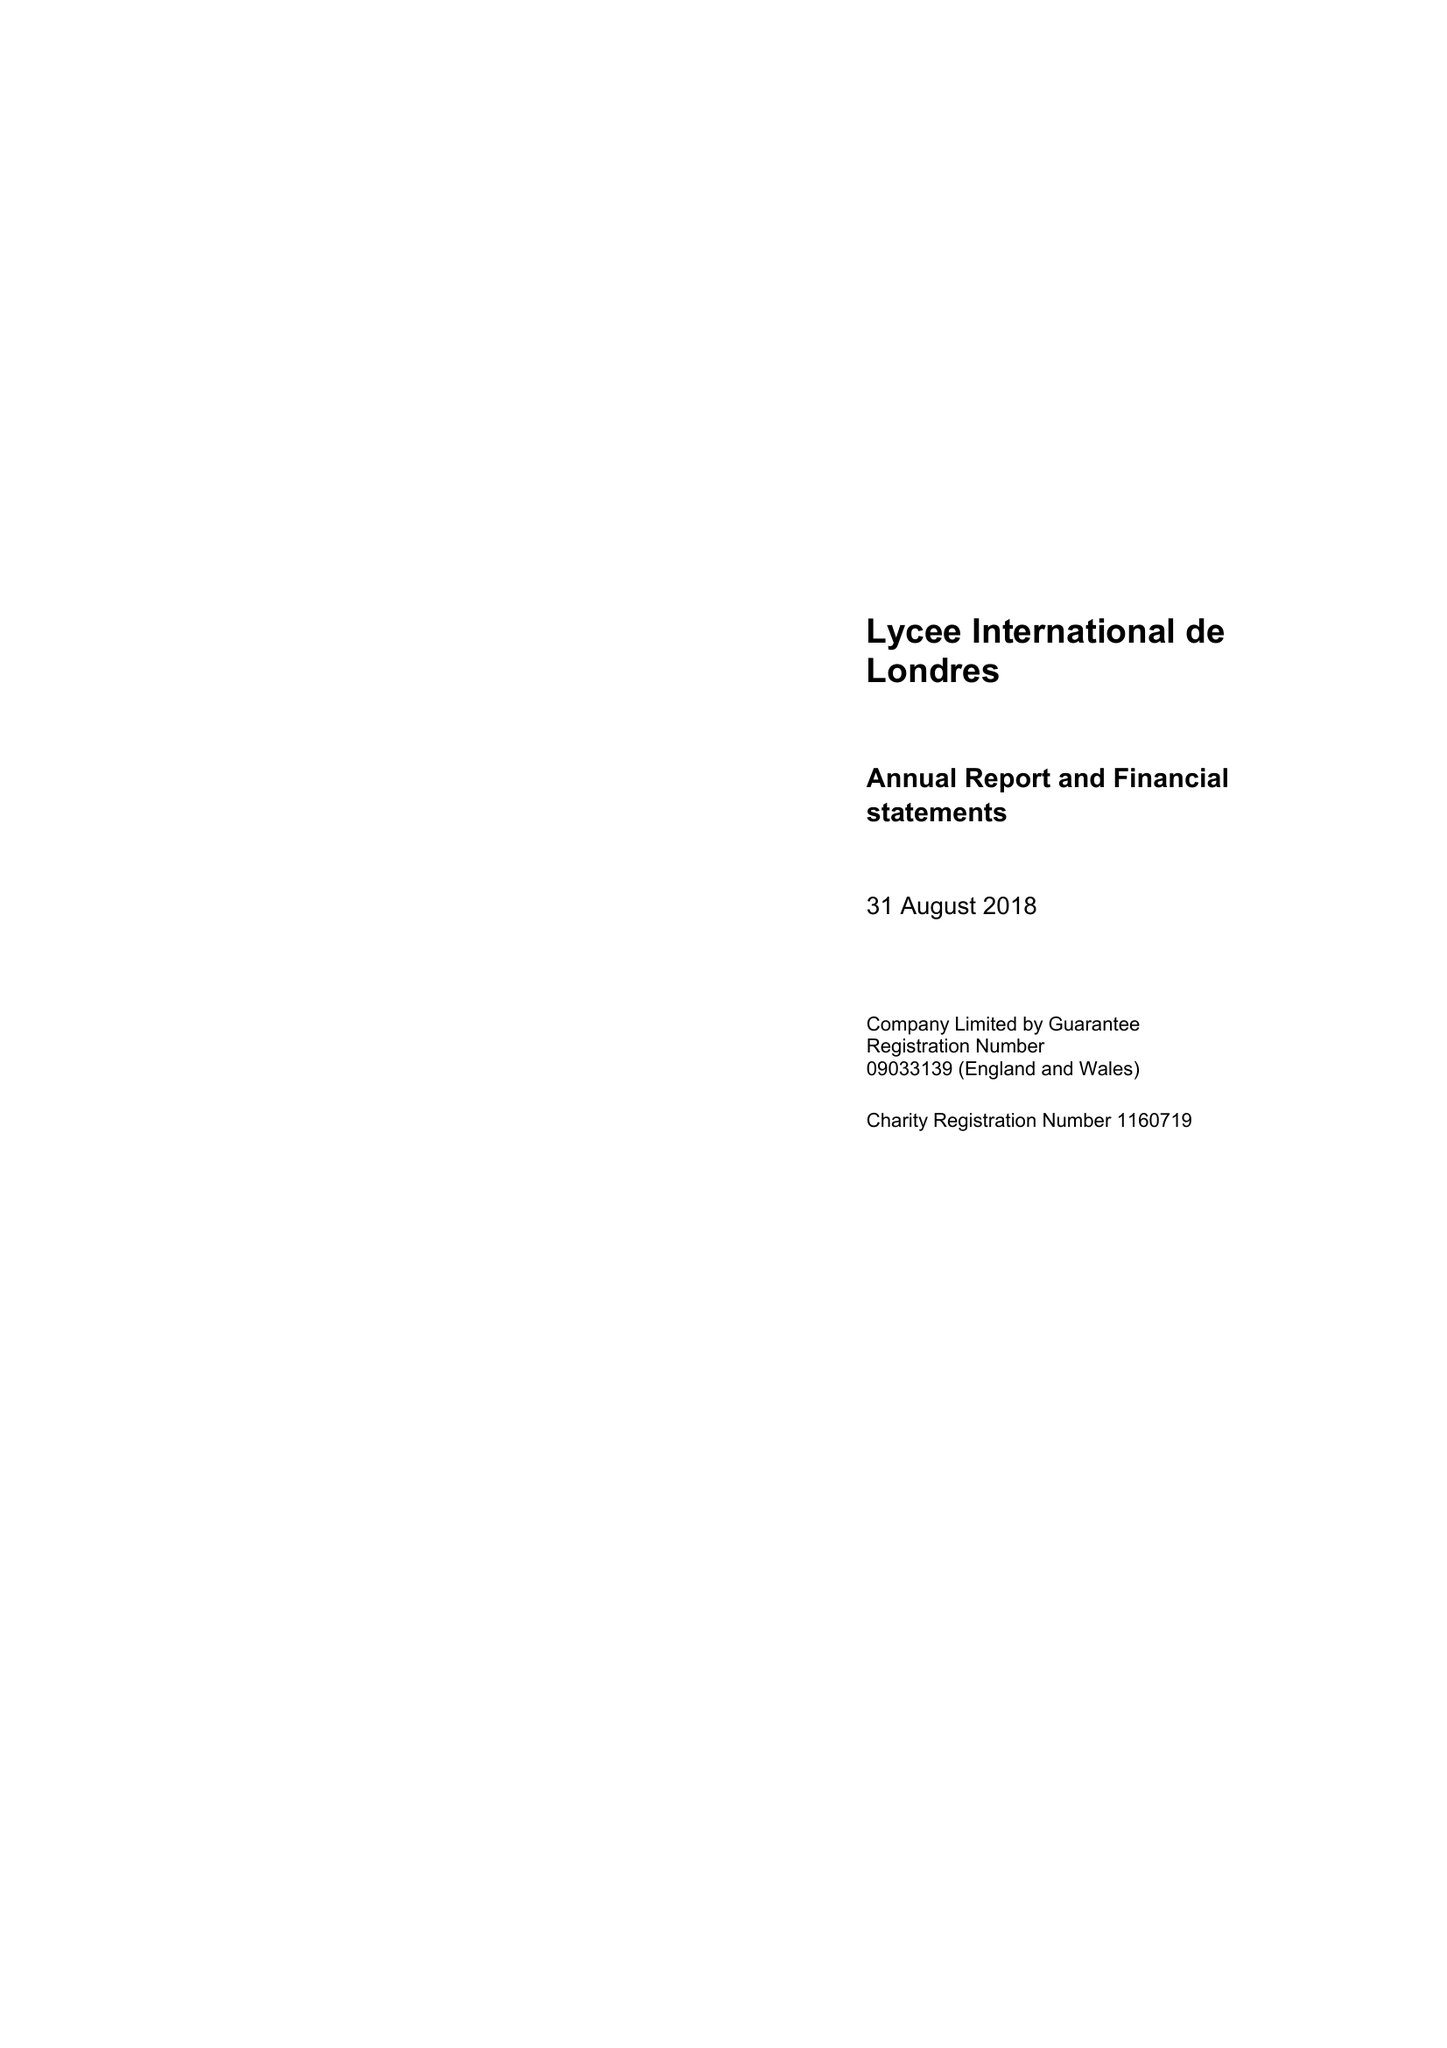What is the value for the charity_name?
Answer the question using a single word or phrase. Lycee International De Londres 